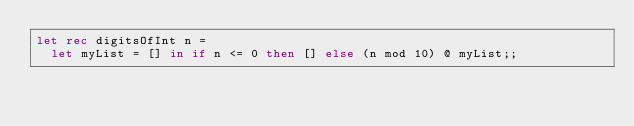Convert code to text. <code><loc_0><loc_0><loc_500><loc_500><_OCaml_>let rec digitsOfInt n =
  let myList = [] in if n <= 0 then [] else (n mod 10) @ myList;;
</code> 